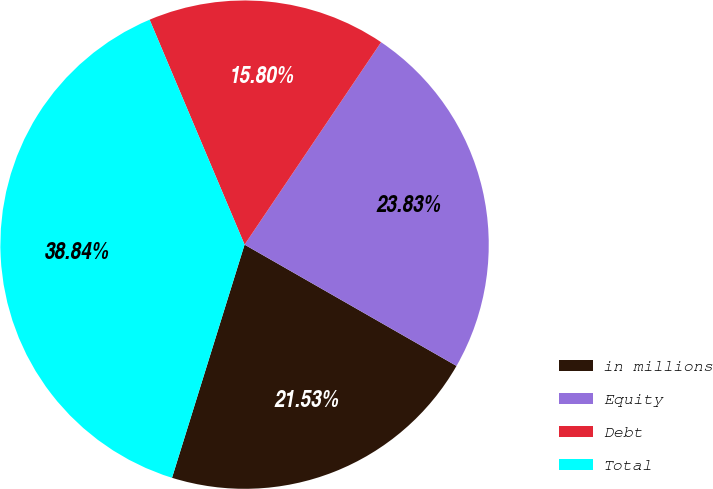Convert chart to OTSL. <chart><loc_0><loc_0><loc_500><loc_500><pie_chart><fcel>in millions<fcel>Equity<fcel>Debt<fcel>Total<nl><fcel>21.53%<fcel>23.83%<fcel>15.8%<fcel>38.84%<nl></chart> 